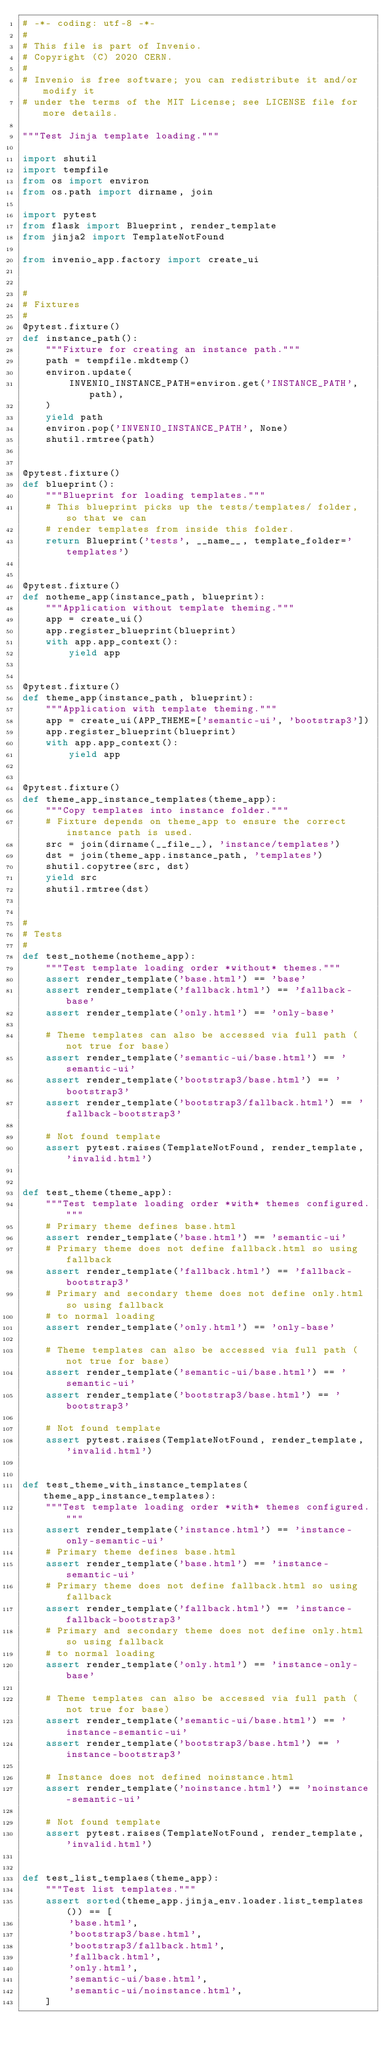<code> <loc_0><loc_0><loc_500><loc_500><_Python_># -*- coding: utf-8 -*-
#
# This file is part of Invenio.
# Copyright (C) 2020 CERN.
#
# Invenio is free software; you can redistribute it and/or modify it
# under the terms of the MIT License; see LICENSE file for more details.

"""Test Jinja template loading."""

import shutil
import tempfile
from os import environ
from os.path import dirname, join

import pytest
from flask import Blueprint, render_template
from jinja2 import TemplateNotFound

from invenio_app.factory import create_ui


#
# Fixtures
#
@pytest.fixture()
def instance_path():
    """Fixture for creating an instance path."""
    path = tempfile.mkdtemp()
    environ.update(
        INVENIO_INSTANCE_PATH=environ.get('INSTANCE_PATH', path),
    )
    yield path
    environ.pop('INVENIO_INSTANCE_PATH', None)
    shutil.rmtree(path)


@pytest.fixture()
def blueprint():
    """Blueprint for loading templates."""
    # This blueprint picks up the tests/templates/ folder, so that we can
    # render templates from inside this folder.
    return Blueprint('tests', __name__, template_folder='templates')


@pytest.fixture()
def notheme_app(instance_path, blueprint):
    """Application without template theming."""
    app = create_ui()
    app.register_blueprint(blueprint)
    with app.app_context():
        yield app


@pytest.fixture()
def theme_app(instance_path, blueprint):
    """Application with template theming."""
    app = create_ui(APP_THEME=['semantic-ui', 'bootstrap3'])
    app.register_blueprint(blueprint)
    with app.app_context():
        yield app


@pytest.fixture()
def theme_app_instance_templates(theme_app):
    """Copy templates into instance folder."""
    # Fixture depends on theme_app to ensure the correct instance path is used.
    src = join(dirname(__file__), 'instance/templates')
    dst = join(theme_app.instance_path, 'templates')
    shutil.copytree(src, dst)
    yield src
    shutil.rmtree(dst)


#
# Tests
#
def test_notheme(notheme_app):
    """Test template loading order *without* themes."""
    assert render_template('base.html') == 'base'
    assert render_template('fallback.html') == 'fallback-base'
    assert render_template('only.html') == 'only-base'

    # Theme templates can also be accessed via full path (not true for base)
    assert render_template('semantic-ui/base.html') == 'semantic-ui'
    assert render_template('bootstrap3/base.html') == 'bootstrap3'
    assert render_template('bootstrap3/fallback.html') == 'fallback-bootstrap3'

    # Not found template
    assert pytest.raises(TemplateNotFound, render_template, 'invalid.html')


def test_theme(theme_app):
    """Test template loading order *with* themes configured."""
    # Primary theme defines base.html
    assert render_template('base.html') == 'semantic-ui'
    # Primary theme does not define fallback.html so using fallback
    assert render_template('fallback.html') == 'fallback-bootstrap3'
    # Primary and secondary theme does not define only.html so using fallback
    # to normal loading
    assert render_template('only.html') == 'only-base'

    # Theme templates can also be accessed via full path (not true for base)
    assert render_template('semantic-ui/base.html') == 'semantic-ui'
    assert render_template('bootstrap3/base.html') == 'bootstrap3'

    # Not found template
    assert pytest.raises(TemplateNotFound, render_template, 'invalid.html')


def test_theme_with_instance_templates(theme_app_instance_templates):
    """Test template loading order *with* themes configured."""
    assert render_template('instance.html') == 'instance-only-semantic-ui'
    # Primary theme defines base.html
    assert render_template('base.html') == 'instance-semantic-ui'
    # Primary theme does not define fallback.html so using fallback
    assert render_template('fallback.html') == 'instance-fallback-bootstrap3'
    # Primary and secondary theme does not define only.html so using fallback
    # to normal loading
    assert render_template('only.html') == 'instance-only-base'

    # Theme templates can also be accessed via full path (not true for base)
    assert render_template('semantic-ui/base.html') == 'instance-semantic-ui'
    assert render_template('bootstrap3/base.html') == 'instance-bootstrap3'

    # Instance does not defined noinstance.html
    assert render_template('noinstance.html') == 'noinstance-semantic-ui'

    # Not found template
    assert pytest.raises(TemplateNotFound, render_template, 'invalid.html')


def test_list_templaes(theme_app):
    """Test list templates."""
    assert sorted(theme_app.jinja_env.loader.list_templates()) == [
        'base.html',
        'bootstrap3/base.html',
        'bootstrap3/fallback.html',
        'fallback.html',
        'only.html',
        'semantic-ui/base.html',
        'semantic-ui/noinstance.html',
    ]
</code> 